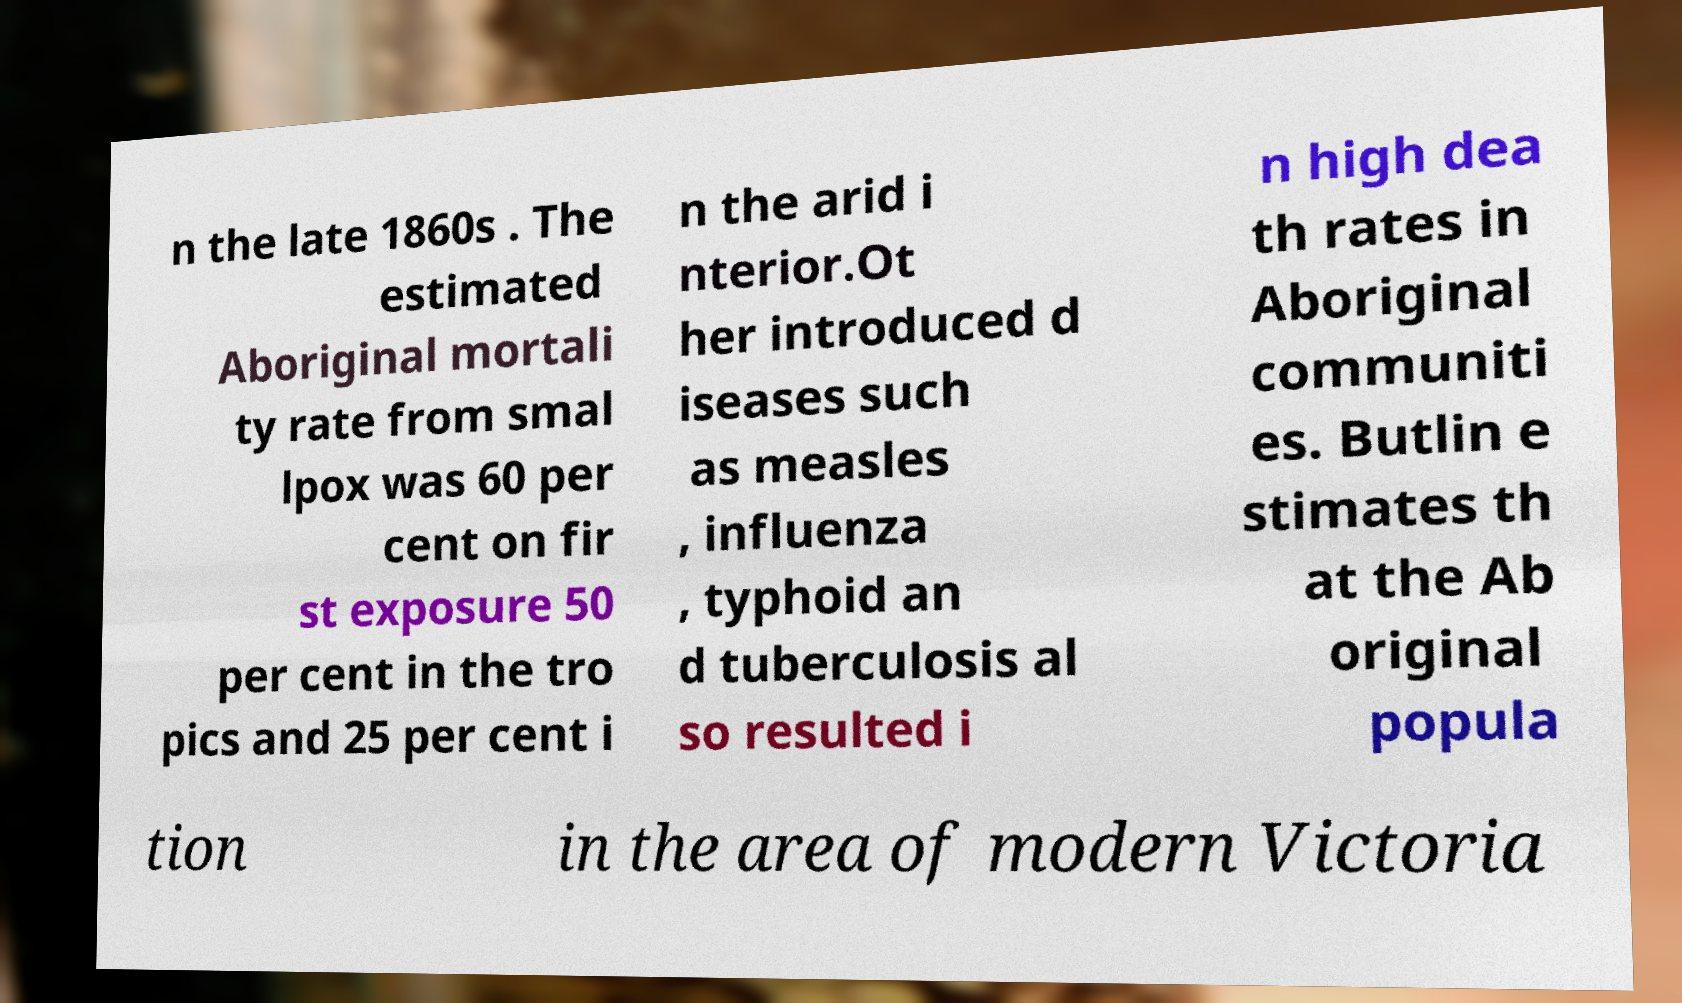Could you assist in decoding the text presented in this image and type it out clearly? n the late 1860s . The estimated Aboriginal mortali ty rate from smal lpox was 60 per cent on fir st exposure 50 per cent in the tro pics and 25 per cent i n the arid i nterior.Ot her introduced d iseases such as measles , influenza , typhoid an d tuberculosis al so resulted i n high dea th rates in Aboriginal communiti es. Butlin e stimates th at the Ab original popula tion in the area of modern Victoria 